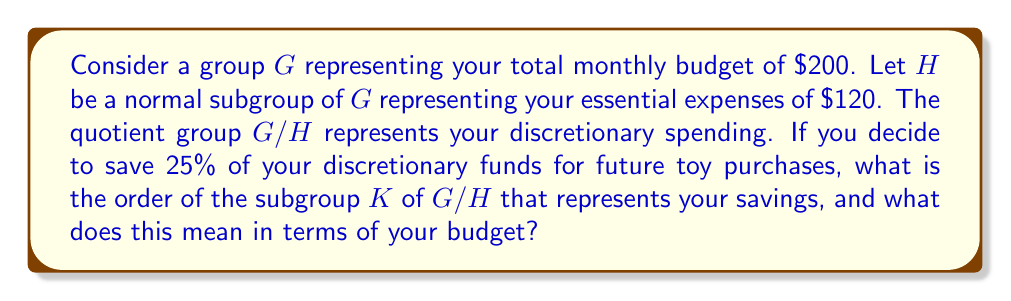Can you answer this question? Let's approach this step-by-step:

1) First, we need to understand what the quotient group $G/H$ represents:
   $|G/H| = |G| / |H| = 200 / 120 = 5/3$

   This means your discretionary spending is $200 - $120 = $80.

2) Now, you want to save 25% of your discretionary funds:
   $0.25 * $80 = $20

3) In group theory terms, we're looking for a subgroup $K$ of $G/H$ that represents this $20 savings.

4) The order of $K$ in $G/H$ would be:
   $|K| = 20 / (200/5) = 20 / 40 = 1/2$

5) In group theory, the order of a subgroup must divide the order of the group. Here, $1/2$ divides $5/3$ (as $5/3 \div 1/2 = 10/3$, which is a whole number).

6) The order of $K$ being $1/2$ means that your savings represent half of one unit in your discretionary spending group.

7) In budgeting terms, this means your $20 savings is half of one $40 unit in your $80 discretionary fund.
Answer: The order of subgroup $K$ is $1/2$, which means your $20 savings represents half of one $40 unit in your discretionary spending group. 